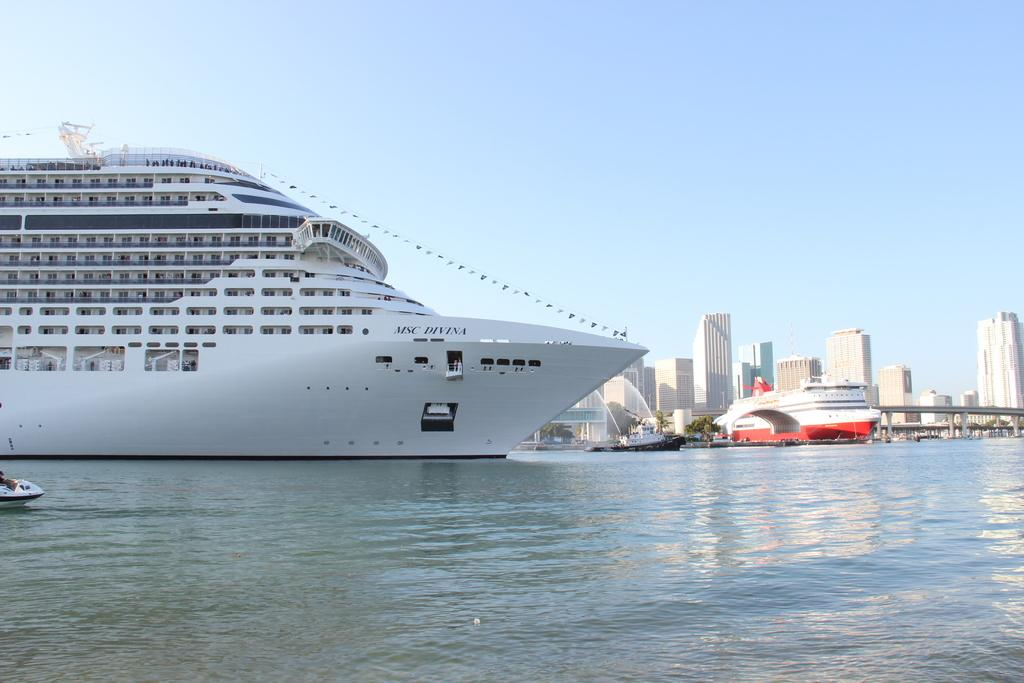What is the main subject in the center of the image? There is a ship, boats, buildings, a bridge, and trees in the center of the image. Can you describe the surrounding environment in the image? There is water visible at the bottom of the image and sky visible at the top of the image. What type of rose can be seen growing on the ship in the image? There are no roses present in the image, and the ship does not have any plants growing on it. 